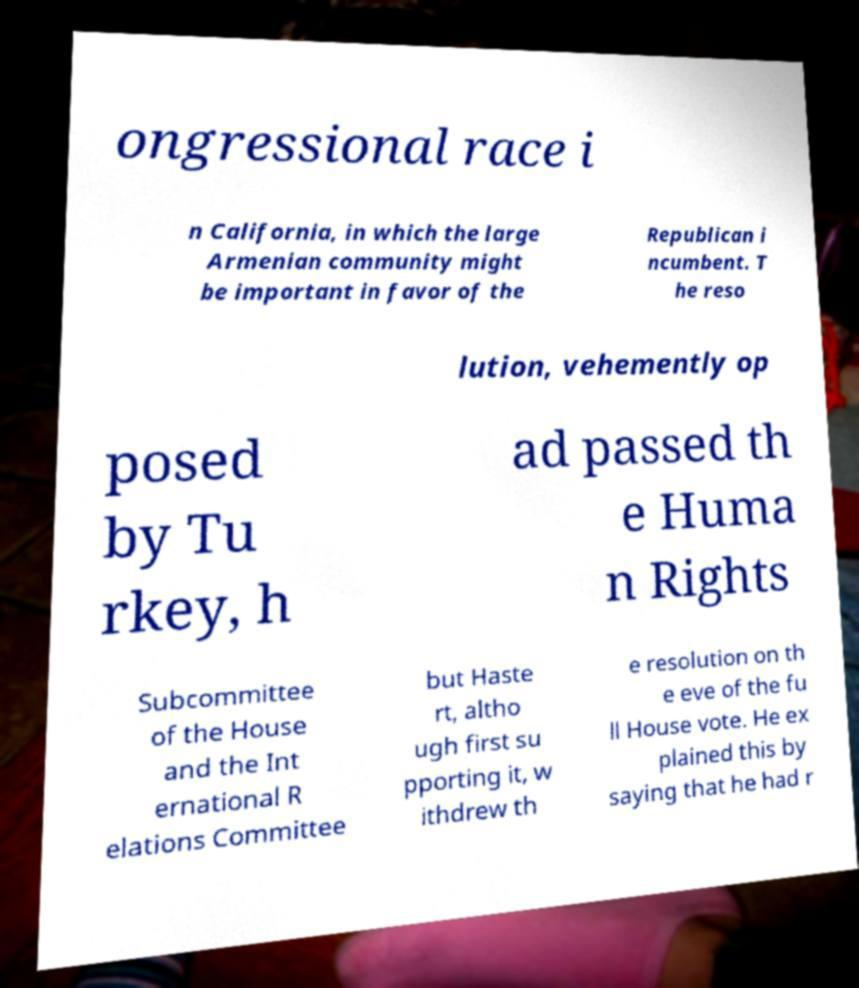Can you accurately transcribe the text from the provided image for me? ongressional race i n California, in which the large Armenian community might be important in favor of the Republican i ncumbent. T he reso lution, vehemently op posed by Tu rkey, h ad passed th e Huma n Rights Subcommittee of the House and the Int ernational R elations Committee but Haste rt, altho ugh first su pporting it, w ithdrew th e resolution on th e eve of the fu ll House vote. He ex plained this by saying that he had r 